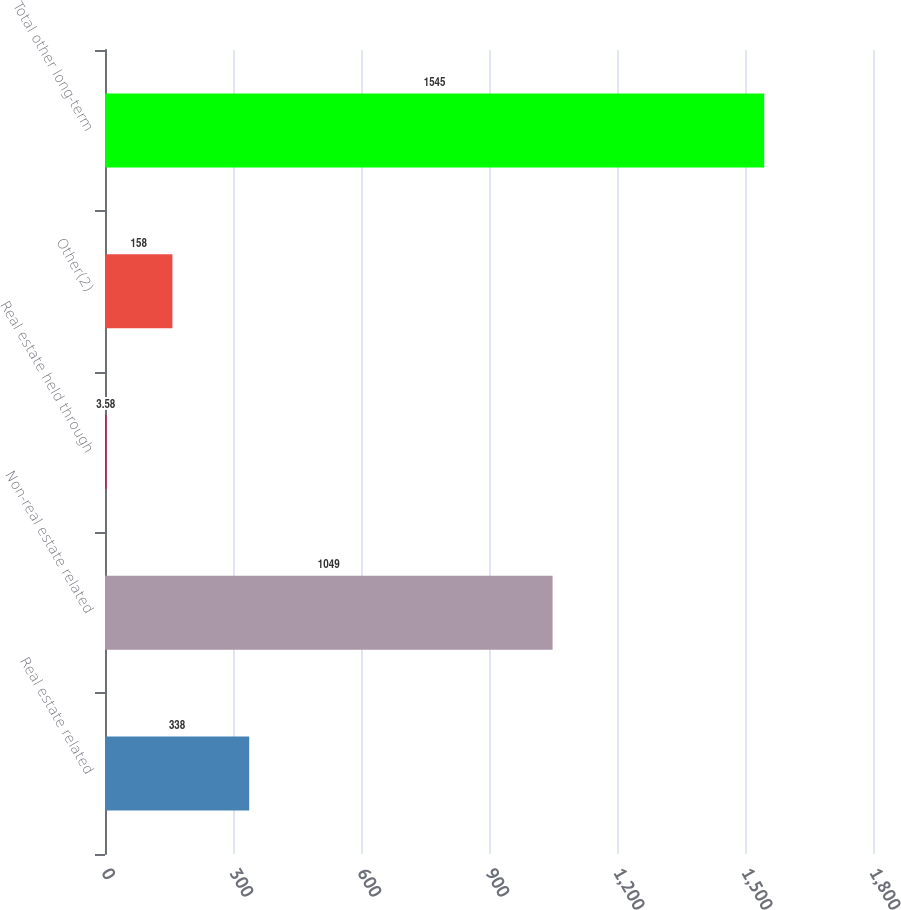Convert chart. <chart><loc_0><loc_0><loc_500><loc_500><bar_chart><fcel>Real estate related<fcel>Non-real estate related<fcel>Real estate held through<fcel>Other(2)<fcel>Total other long-term<nl><fcel>338<fcel>1049<fcel>3.58<fcel>158<fcel>1545<nl></chart> 